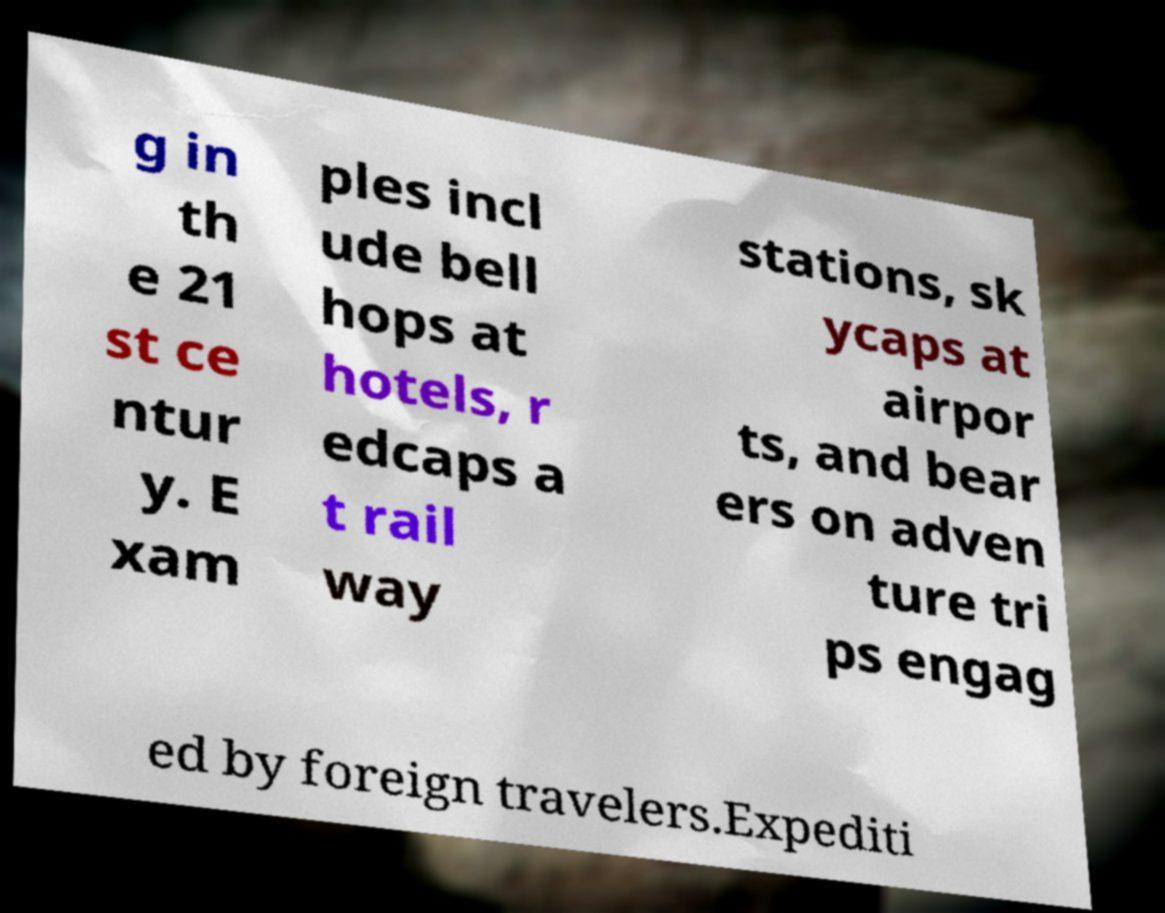Please identify and transcribe the text found in this image. g in th e 21 st ce ntur y. E xam ples incl ude bell hops at hotels, r edcaps a t rail way stations, sk ycaps at airpor ts, and bear ers on adven ture tri ps engag ed by foreign travelers.Expediti 